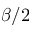Convert formula to latex. <formula><loc_0><loc_0><loc_500><loc_500>\beta / 2</formula> 